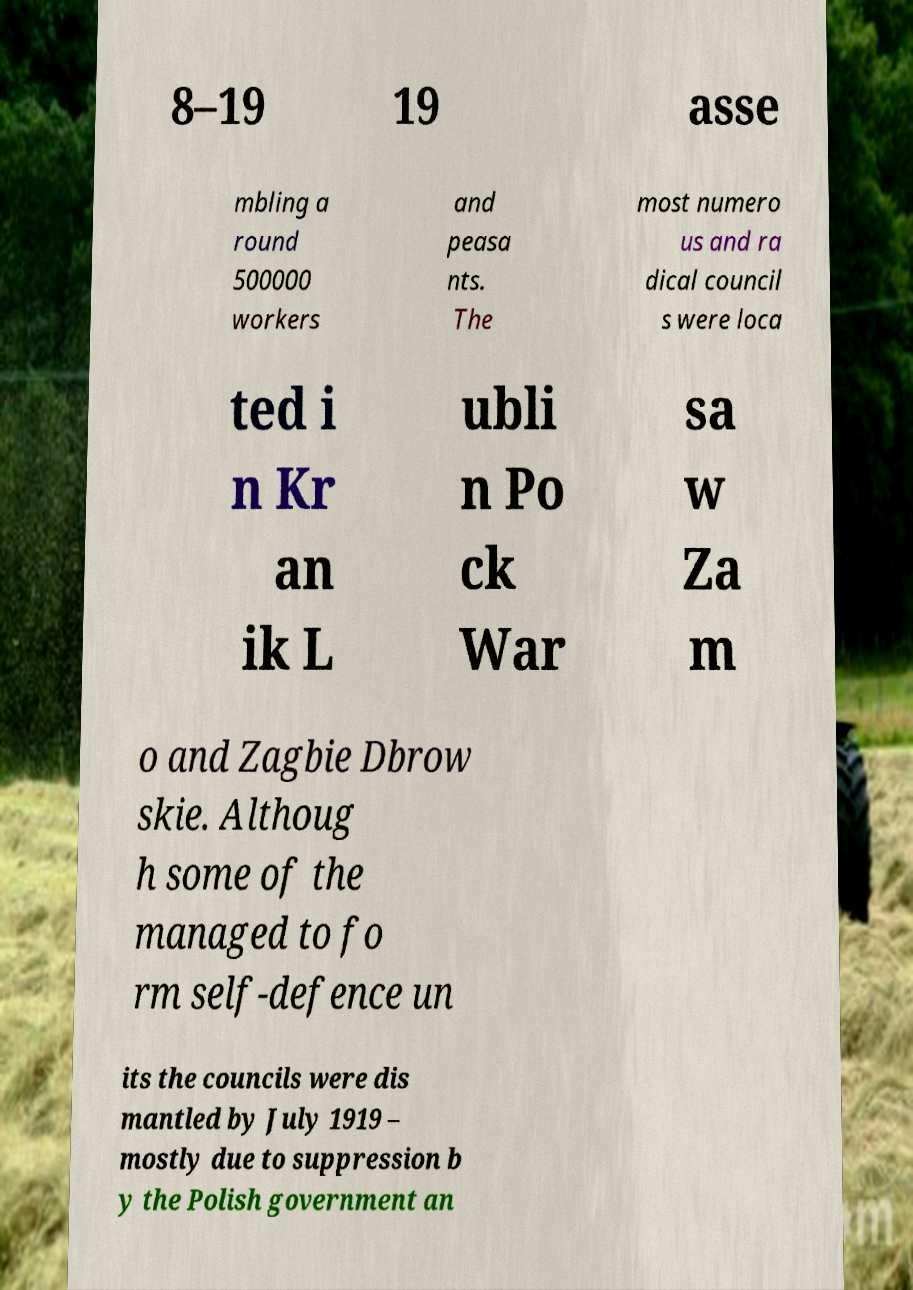Could you extract and type out the text from this image? 8–19 19 asse mbling a round 500000 workers and peasa nts. The most numero us and ra dical council s were loca ted i n Kr an ik L ubli n Po ck War sa w Za m o and Zagbie Dbrow skie. Althoug h some of the managed to fo rm self-defence un its the councils were dis mantled by July 1919 – mostly due to suppression b y the Polish government an 